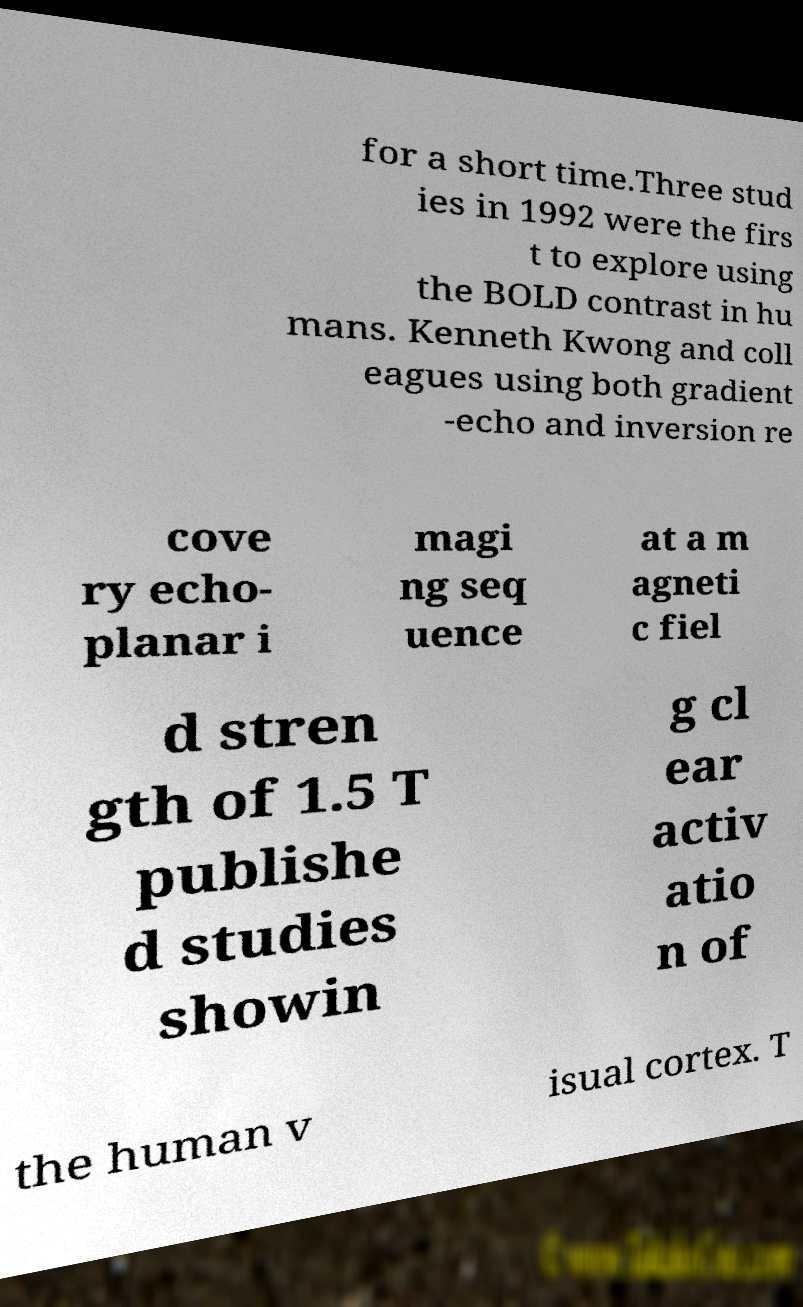Could you extract and type out the text from this image? for a short time.Three stud ies in 1992 were the firs t to explore using the BOLD contrast in hu mans. Kenneth Kwong and coll eagues using both gradient -echo and inversion re cove ry echo- planar i magi ng seq uence at a m agneti c fiel d stren gth of 1.5 T publishe d studies showin g cl ear activ atio n of the human v isual cortex. T 